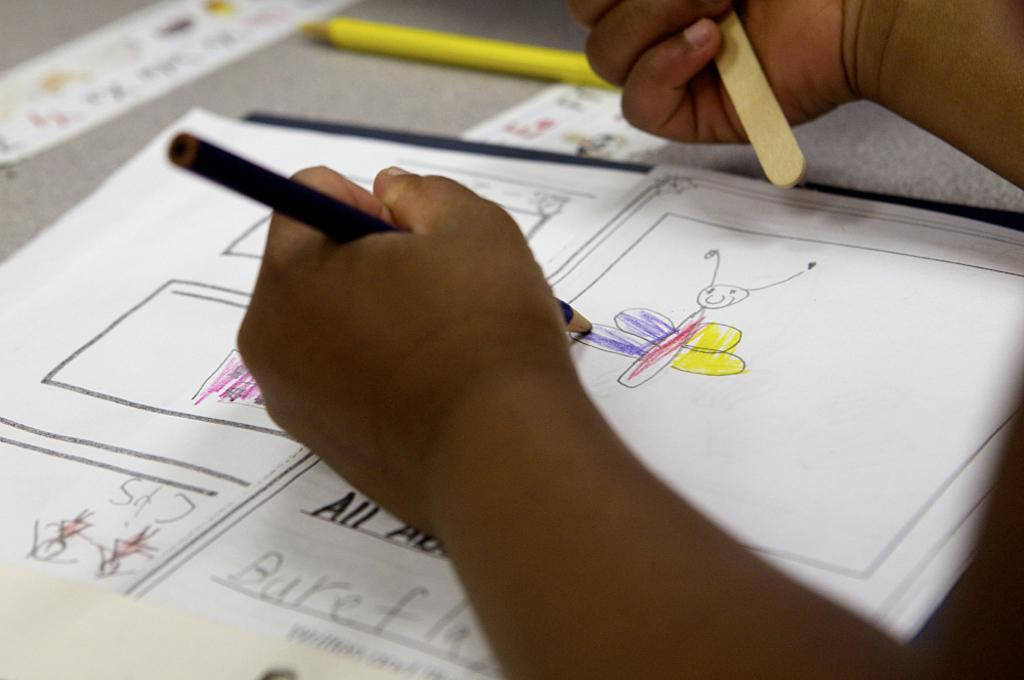<image>
Present a compact description of the photo's key features. Person drawing a butterfly with the word "All" under his hand. 